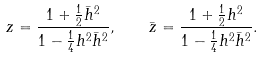Convert formula to latex. <formula><loc_0><loc_0><loc_500><loc_500>z = { \frac { 1 + { \frac { 1 } { 2 } } \bar { h } ^ { 2 } } { 1 - { \frac { 1 } { 4 } } h ^ { 2 } \bar { h } ^ { 2 } } } , \quad \bar { z } = { \frac { 1 + { \frac { 1 } { 2 } } h ^ { 2 } } { 1 - { \frac { 1 } { 4 } } h ^ { 2 } \bar { h } ^ { 2 } } } .</formula> 